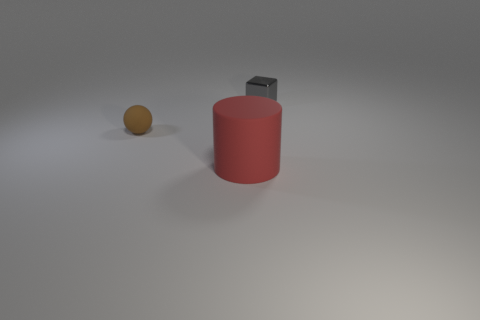Subtract all brown cylinders. Subtract all gray balls. How many cylinders are left? 1 Add 2 red matte objects. How many objects exist? 5 Subtract all blocks. How many objects are left? 2 Add 2 small green metallic cubes. How many small green metallic cubes exist? 2 Subtract 0 cyan cylinders. How many objects are left? 3 Subtract all big purple shiny things. Subtract all small rubber things. How many objects are left? 2 Add 2 large objects. How many large objects are left? 3 